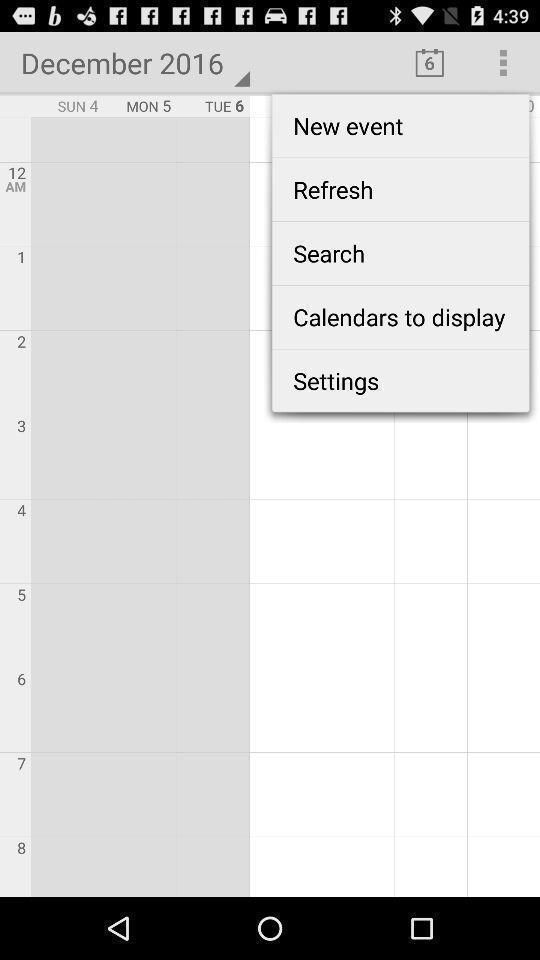Give me a summary of this screen capture. Screen shows calendar details. 